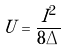<formula> <loc_0><loc_0><loc_500><loc_500>U = \frac { I ^ { 2 } } { 8 \Delta }</formula> 